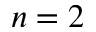<formula> <loc_0><loc_0><loc_500><loc_500>n = 2</formula> 